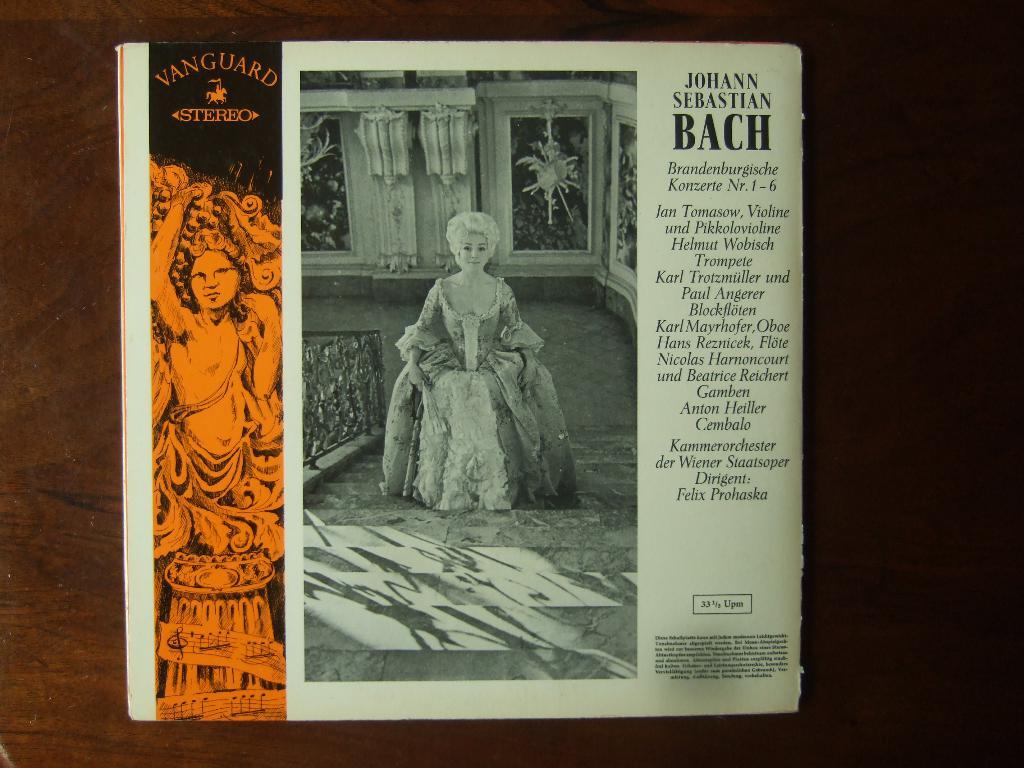What speed should this be played?
Provide a succinct answer. 33 1/2. 